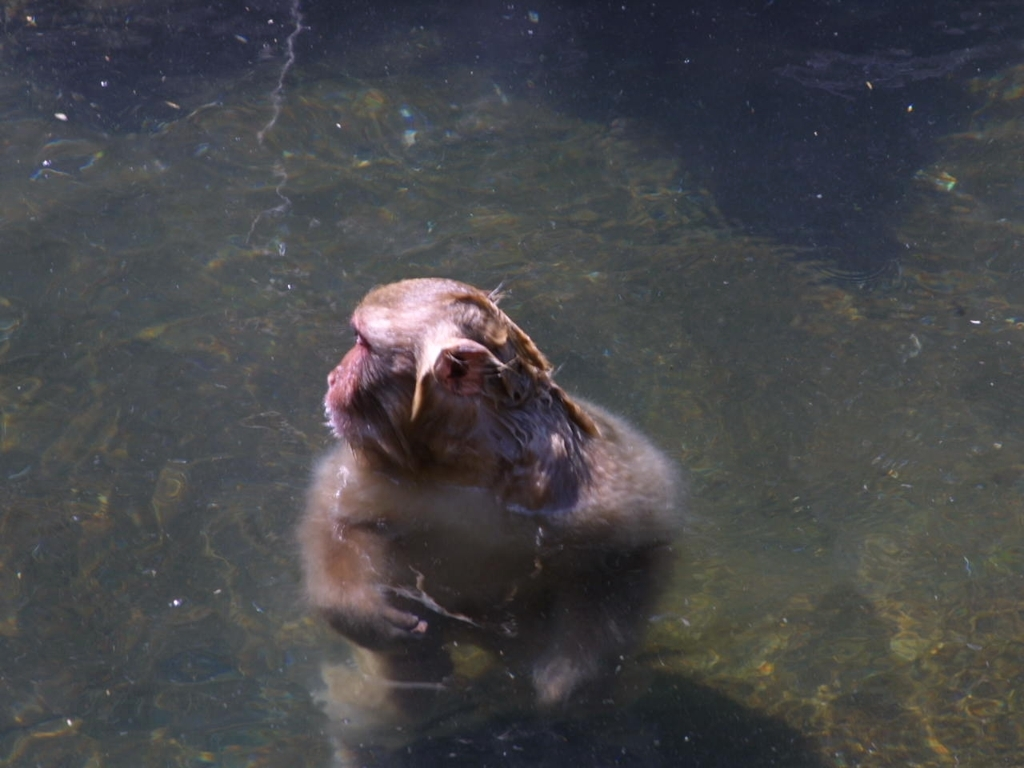What time of day does this photo seem to have been taken? The brightness and quality of the light suggest it might be midday, when the sun is high, leading to the reflections and overexposure on the water's surface. 